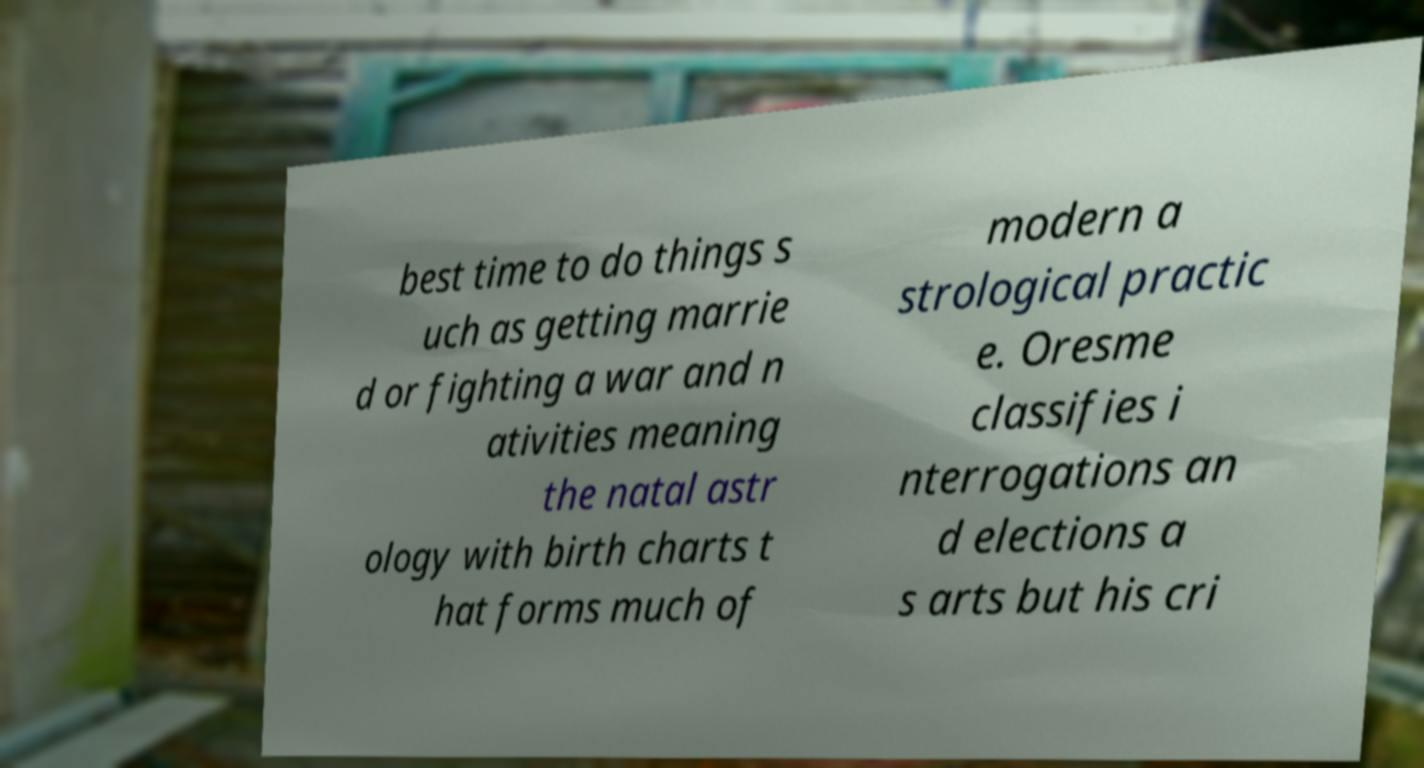Can you read and provide the text displayed in the image?This photo seems to have some interesting text. Can you extract and type it out for me? best time to do things s uch as getting marrie d or fighting a war and n ativities meaning the natal astr ology with birth charts t hat forms much of modern a strological practic e. Oresme classifies i nterrogations an d elections a s arts but his cri 